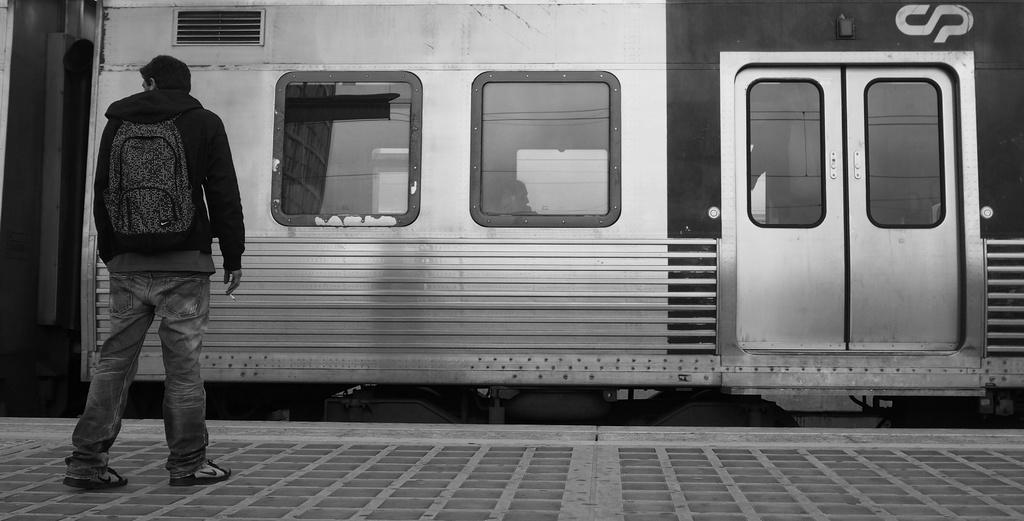Describe this image in one or two sentences. In this picture I can observe a person standing on the platform on the left side. In the middle of the picture I can observe train on the track. This is a black and white image. 